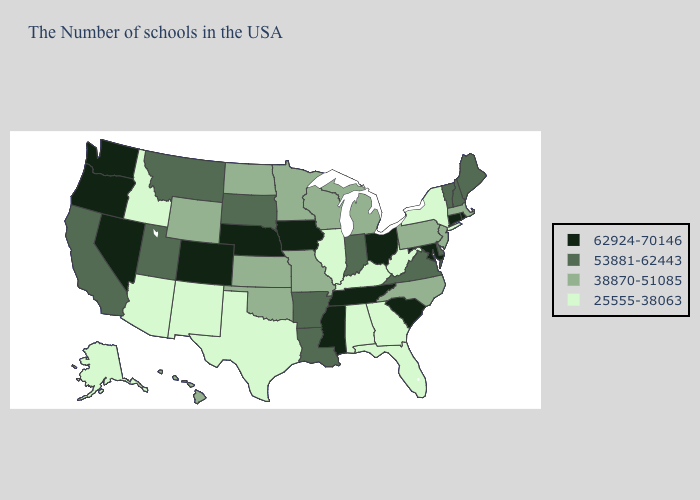How many symbols are there in the legend?
Keep it brief. 4. Does the first symbol in the legend represent the smallest category?
Write a very short answer. No. What is the lowest value in states that border New Hampshire?
Short answer required. 38870-51085. Name the states that have a value in the range 53881-62443?
Be succinct. Maine, New Hampshire, Vermont, Delaware, Virginia, Indiana, Louisiana, Arkansas, South Dakota, Utah, Montana, California. What is the highest value in the MidWest ?
Give a very brief answer. 62924-70146. Name the states that have a value in the range 25555-38063?
Be succinct. New York, West Virginia, Florida, Georgia, Kentucky, Alabama, Illinois, Texas, New Mexico, Arizona, Idaho, Alaska. What is the value of Missouri?
Short answer required. 38870-51085. Does Illinois have the highest value in the USA?
Answer briefly. No. What is the value of Idaho?
Answer briefly. 25555-38063. Does the map have missing data?
Give a very brief answer. No. What is the lowest value in the MidWest?
Give a very brief answer. 25555-38063. Does North Carolina have a lower value than Colorado?
Answer briefly. Yes. What is the value of South Dakota?
Answer briefly. 53881-62443. What is the value of New Hampshire?
Be succinct. 53881-62443. What is the value of North Dakota?
Concise answer only. 38870-51085. 